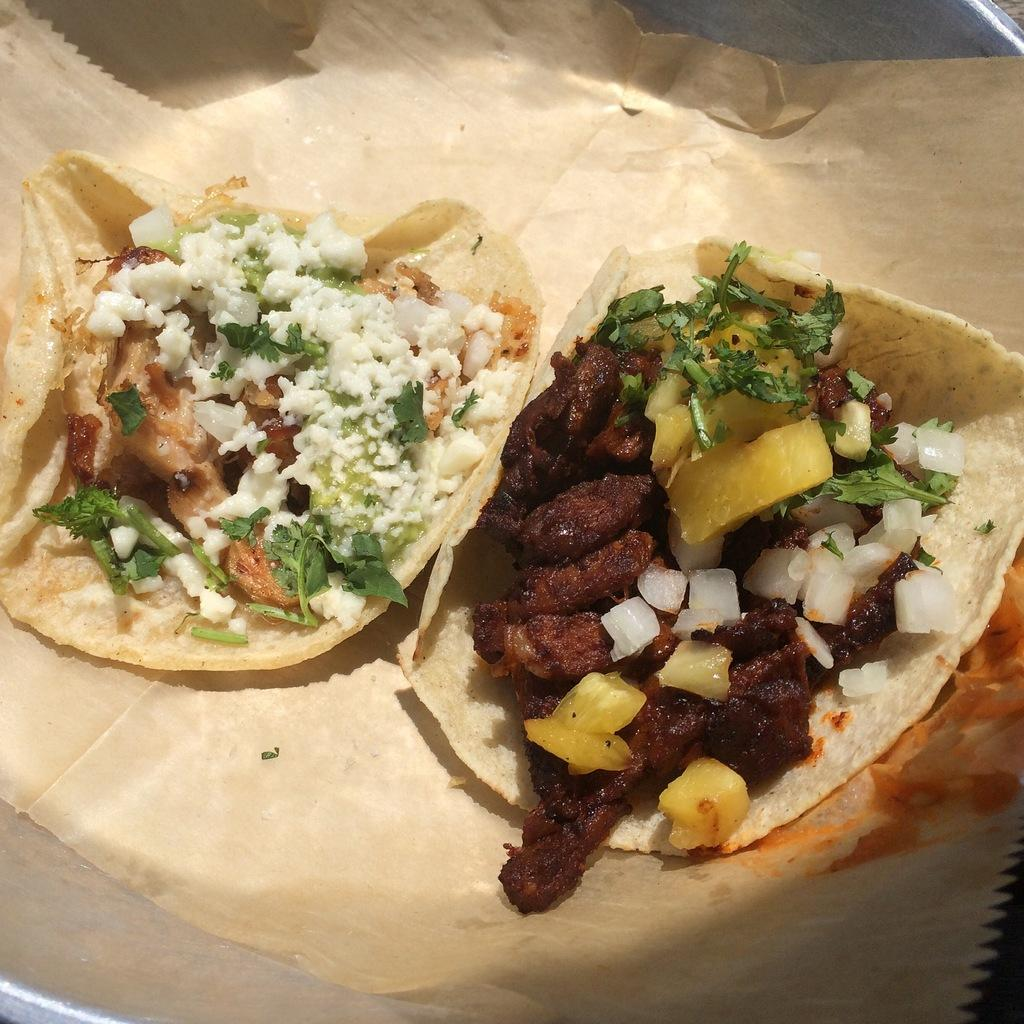What is the main subject of the image? The main subject of the image is food. What is the food placed on? The food is placed on a brown color paper. How can you describe the appearance of the food? The food is colorful. Is there any other object visible in the image? Yes, the brown color paper is on a silver color plate. What type of winter activity is taking place on the island in the image? There is no reference to winter or an island in the image; it features food on a brown color paper and a silver color plate. 